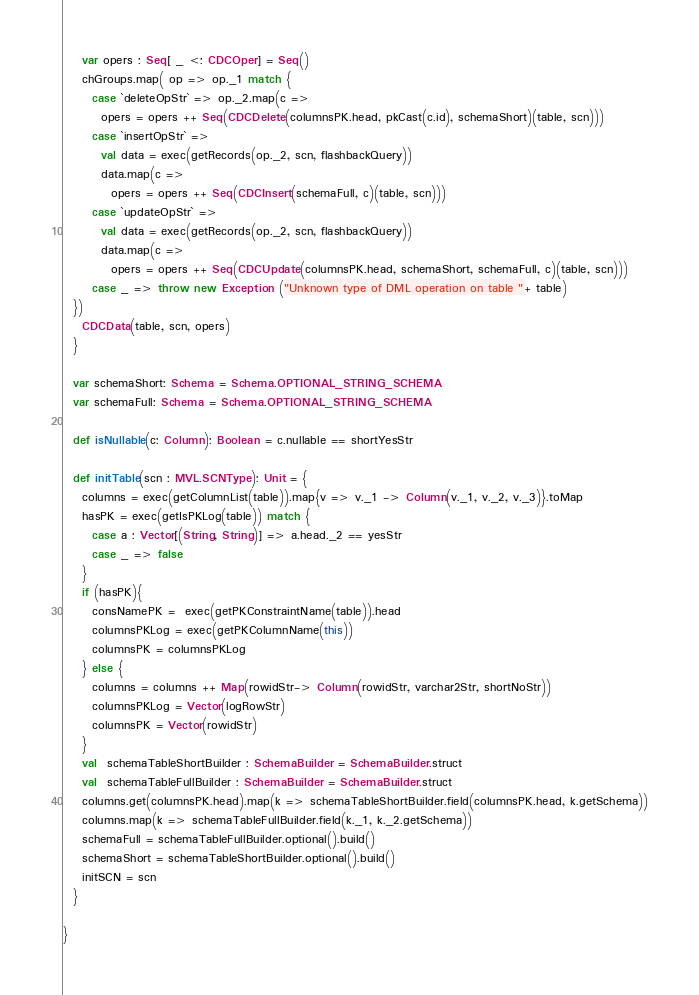Convert code to text. <code><loc_0><loc_0><loc_500><loc_500><_Scala_>    var opers : Seq[ _ <: CDCOper] = Seq()
    chGroups.map( op => op._1 match {
      case `deleteOpStr` => op._2.map(c =>
        opers = opers ++ Seq(CDCDelete(columnsPK.head, pkCast(c.id), schemaShort)(table, scn)))
      case `insertOpStr` =>
        val data = exec(getRecords(op._2, scn, flashbackQuery))
        data.map(c =>
          opers = opers ++ Seq(CDCInsert(schemaFull, c)(table, scn)))
      case `updateOpStr` =>
        val data = exec(getRecords(op._2, scn, flashbackQuery))
        data.map(c =>
          opers = opers ++ Seq(CDCUpdate(columnsPK.head, schemaShort, schemaFull, c)(table, scn)))
      case _ => throw new Exception ("Unknown type of DML operation on table "+ table)
  })
    CDCData(table, scn, opers)
  }

  var schemaShort: Schema = Schema.OPTIONAL_STRING_SCHEMA
  var schemaFull: Schema = Schema.OPTIONAL_STRING_SCHEMA

  def isNullable(c: Column): Boolean = c.nullable == shortYesStr

  def initTable(scn : MVL.SCNType): Unit = {
    columns = exec(getColumnList(table)).map{v => v._1 -> Column(v._1, v._2, v._3)}.toMap
    hasPK = exec(getIsPKLog(table)) match {
      case a : Vector[(String, String)] => a.head._2 == yesStr
      case _ => false
    }
    if (hasPK){
      consNamePK =  exec(getPKConstraintName(table)).head
      columnsPKLog = exec(getPKColumnName(this))
      columnsPK = columnsPKLog
    } else {
      columns = columns ++ Map(rowidStr-> Column(rowidStr, varchar2Str, shortNoStr))
      columnsPKLog = Vector(logRowStr)
      columnsPK = Vector(rowidStr)
    }
    val  schemaTableShortBuilder : SchemaBuilder = SchemaBuilder.struct
    val  schemaTableFullBuilder : SchemaBuilder = SchemaBuilder.struct
    columns.get(columnsPK.head).map(k => schemaTableShortBuilder.field(columnsPK.head, k.getSchema))
    columns.map(k => schemaTableFullBuilder.field(k._1, k._2.getSchema))
    schemaFull = schemaTableFullBuilder.optional().build()
    schemaShort = schemaTableShortBuilder.optional().build()
    initSCN = scn
  }

}
</code> 